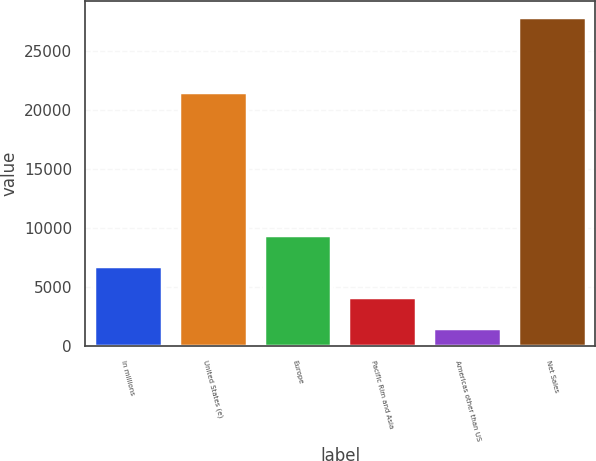Convert chart. <chart><loc_0><loc_0><loc_500><loc_500><bar_chart><fcel>In millions<fcel>United States (e)<fcel>Europe<fcel>Pacific Rim and Asia<fcel>Americas other than US<fcel>Net Sales<nl><fcel>6813.8<fcel>21523<fcel>9441.2<fcel>4186.4<fcel>1559<fcel>27833<nl></chart> 